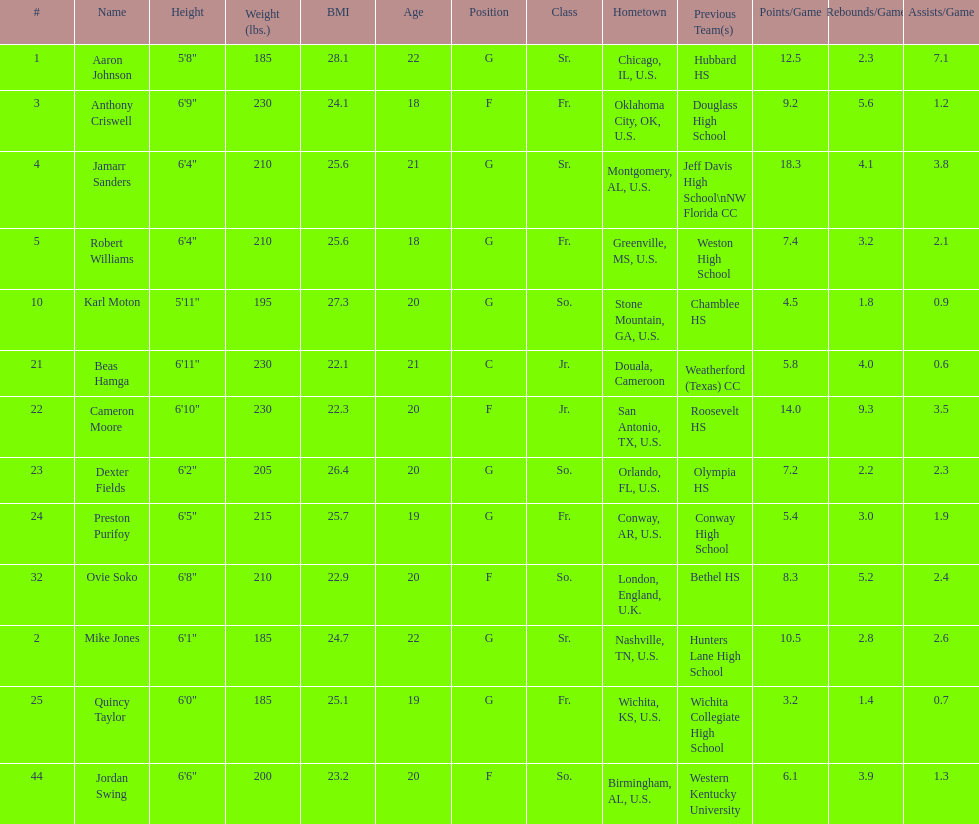How many players come from alabama? 2. 